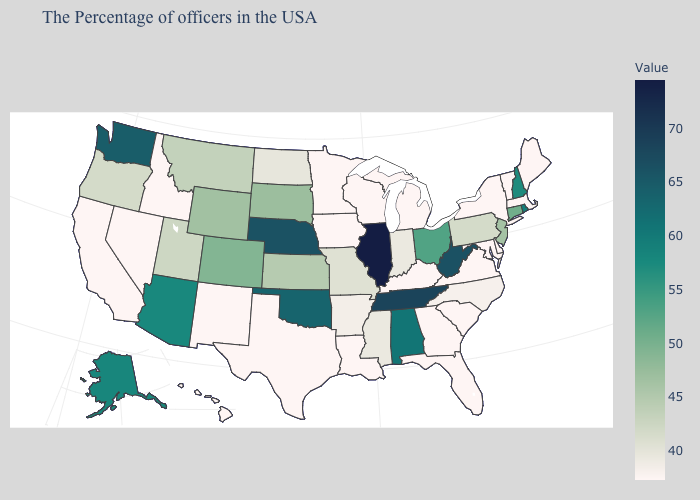Which states have the lowest value in the MidWest?
Answer briefly. Michigan, Wisconsin, Minnesota, Iowa. Among the states that border Nevada , which have the highest value?
Write a very short answer. Arizona. Among the states that border Illinois , which have the highest value?
Short answer required. Missouri. Does the map have missing data?
Keep it brief. No. Does the map have missing data?
Be succinct. No. Which states have the lowest value in the USA?
Be succinct. Maine, Massachusetts, Vermont, New York, Delaware, Maryland, Virginia, South Carolina, Florida, Georgia, Michigan, Kentucky, Wisconsin, Louisiana, Minnesota, Iowa, Texas, New Mexico, Idaho, Nevada, California, Hawaii. 